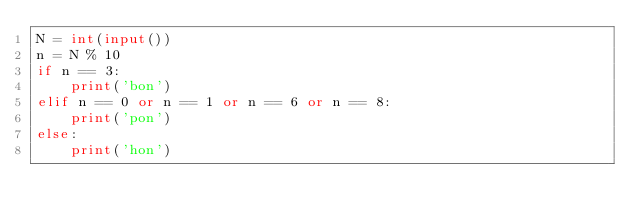<code> <loc_0><loc_0><loc_500><loc_500><_Python_>N = int(input())
n = N % 10
if n == 3:
    print('bon')
elif n == 0 or n == 1 or n == 6 or n == 8:
    print('pon')
else:
    print('hon')</code> 